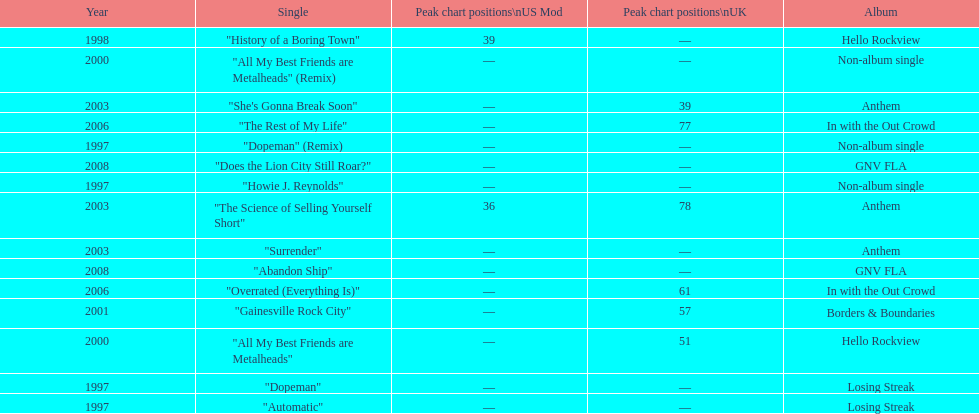Compare the chart positions between the us and the uk for the science of selling yourself short, where did it do better? US. 